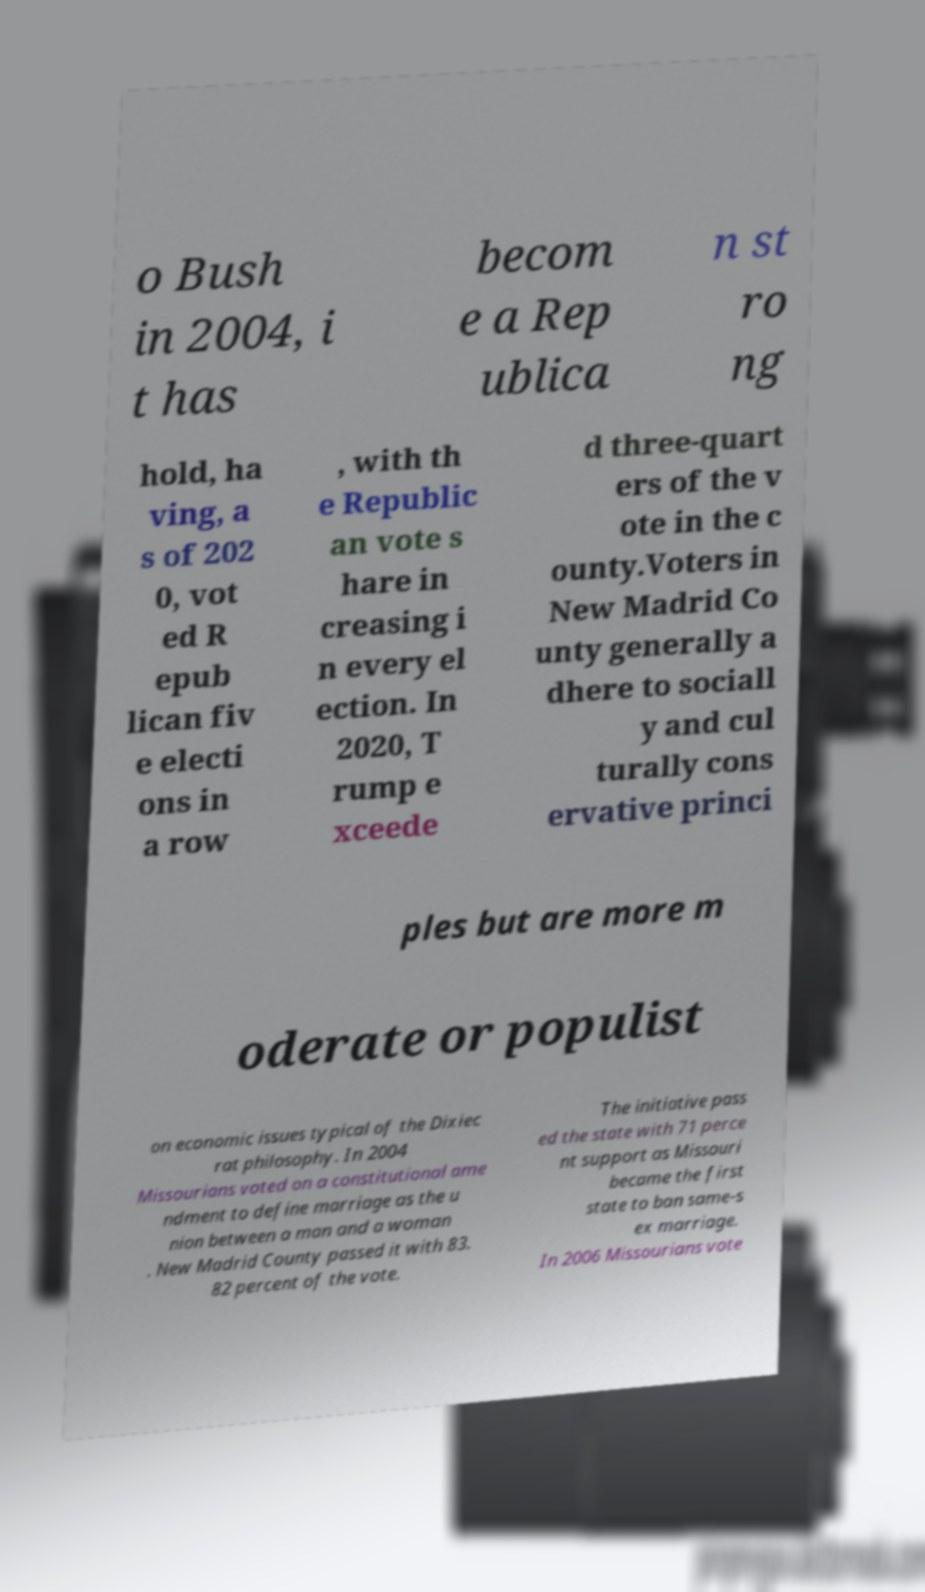I need the written content from this picture converted into text. Can you do that? o Bush in 2004, i t has becom e a Rep ublica n st ro ng hold, ha ving, a s of 202 0, vot ed R epub lican fiv e electi ons in a row , with th e Republic an vote s hare in creasing i n every el ection. In 2020, T rump e xceede d three-quart ers of the v ote in the c ounty.Voters in New Madrid Co unty generally a dhere to sociall y and cul turally cons ervative princi ples but are more m oderate or populist on economic issues typical of the Dixiec rat philosophy. In 2004 Missourians voted on a constitutional ame ndment to define marriage as the u nion between a man and a woman . New Madrid County passed it with 83. 82 percent of the vote. The initiative pass ed the state with 71 perce nt support as Missouri became the first state to ban same-s ex marriage. In 2006 Missourians vote 